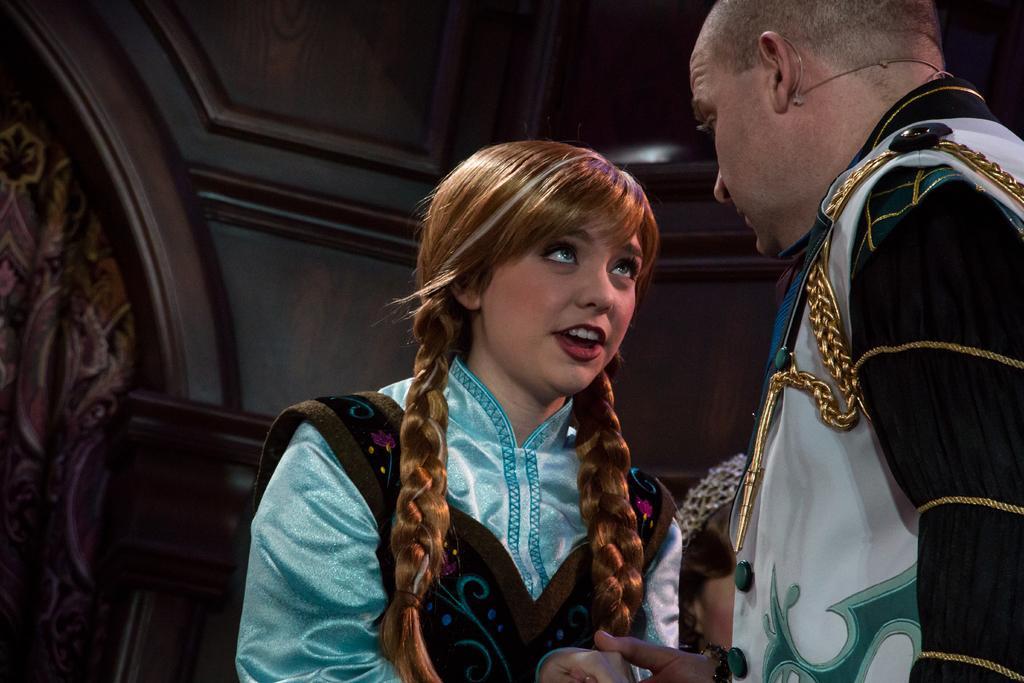Please provide a concise description of this image. In this image, we can see a man and a girl. In the background, there is building. 